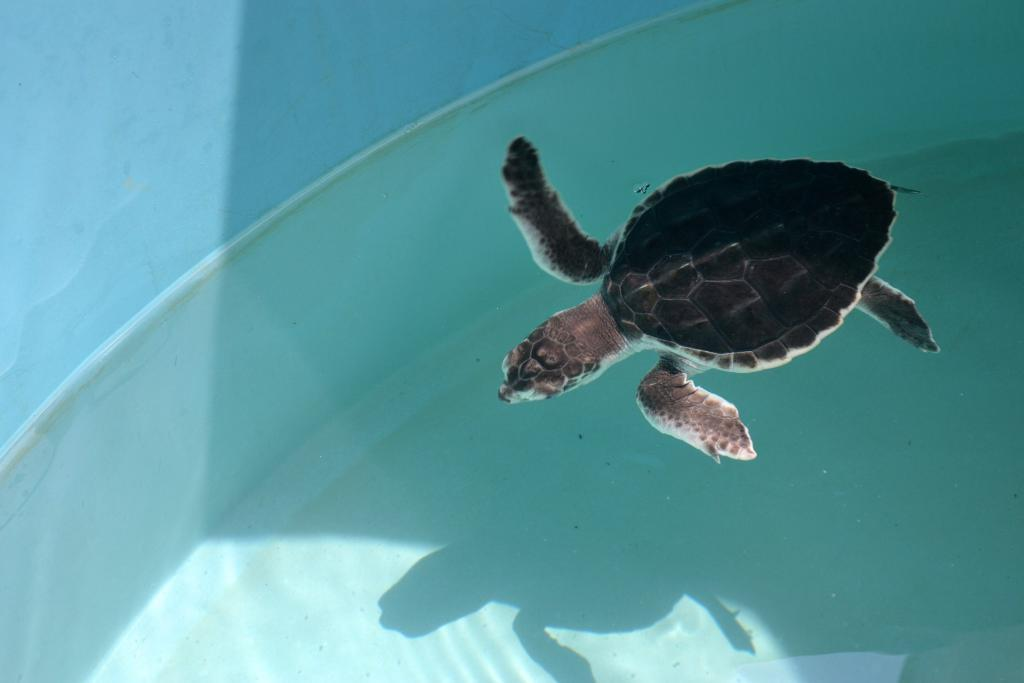What object is present in the image that can hold water? There is a tub in the image. What animal is inside the tub? There is a tortoise in the tub. What is the tortoise doing in the tub? The tortoise is in water. What color is the wall visible in the background of the image? There is a blue wall in the background of the image. What type of chain is holding the tortoise in the air in the image? There is no chain present in the image, and the tortoise is not being held in the air. 